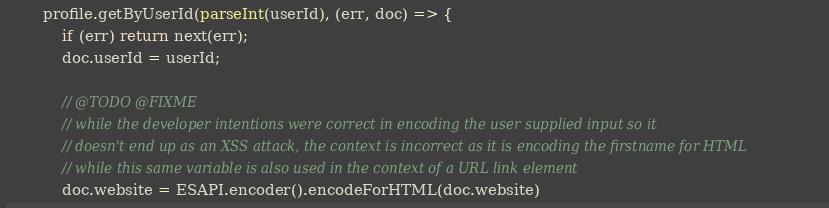<code> <loc_0><loc_0><loc_500><loc_500><_JavaScript_>
        profile.getByUserId(parseInt(userId), (err, doc) => {
            if (err) return next(err);
            doc.userId = userId;

            // @TODO @FIXME
            // while the developer intentions were correct in encoding the user supplied input so it
            // doesn't end up as an XSS attack, the context is incorrect as it is encoding the firstname for HTML
            // while this same variable is also used in the context of a URL link element
            doc.website = ESAPI.encoder().encodeForHTML(doc.website)</code> 